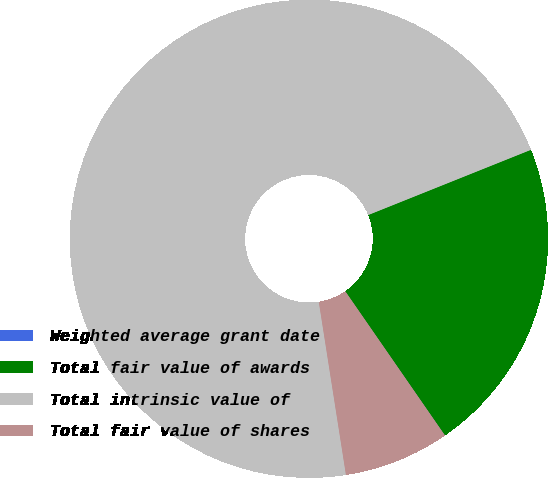Convert chart. <chart><loc_0><loc_0><loc_500><loc_500><pie_chart><fcel>Weighted average grant date<fcel>Total fair value of awards<fcel>Total intrinsic value of<fcel>Total fair value of shares<nl><fcel>0.01%<fcel>21.43%<fcel>71.41%<fcel>7.15%<nl></chart> 